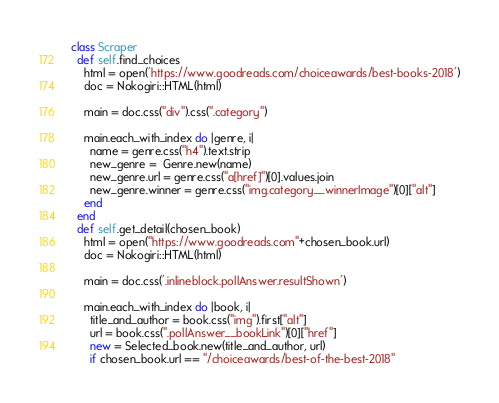Convert code to text. <code><loc_0><loc_0><loc_500><loc_500><_Ruby_>class Scraper
  def self.find_choices
    html = open('https://www.goodreads.com/choiceawards/best-books-2018')
    doc = Nokogiri::HTML(html)

    main = doc.css("div").css(".category")

    main.each_with_index do |genre, i|
      name = genre.css("h4").text.strip
      new_genre =  Genre.new(name)
      new_genre.url = genre.css("a[href]")[0].values.join
      new_genre.winner = genre.css("img.category__winnerImage")[0]["alt"]
    end
  end
  def self.get_detail(chosen_book)
    html = open("https://www.goodreads.com"+chosen_book.url)
    doc = Nokogiri::HTML(html)

    main = doc.css('.inlineblock.pollAnswer.resultShown')

    main.each_with_index do |book, i|
      title_and_author = book.css("img").first["alt"]
      url = book.css(".pollAnswer__bookLink")[0]["href"]
      new = Selected_book.new(title_and_author, url)
      if chosen_book.url == "/choiceawards/best-of-the-best-2018"</code> 